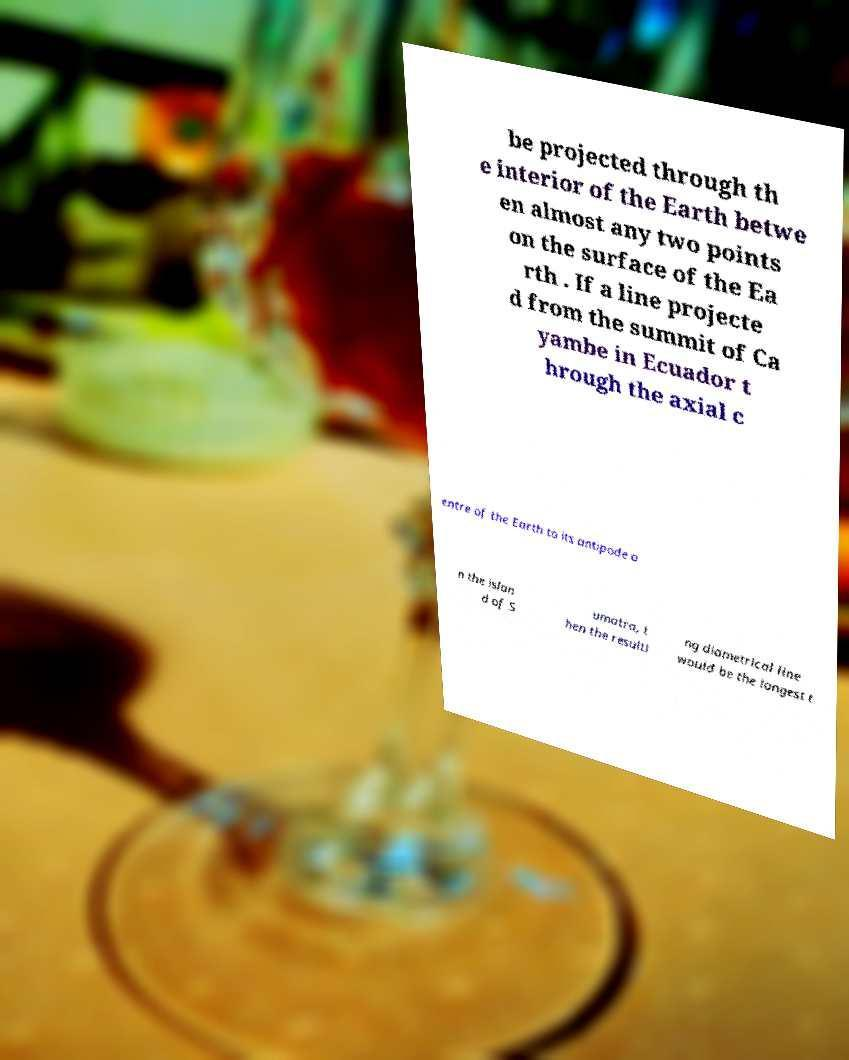What messages or text are displayed in this image? I need them in a readable, typed format. be projected through th e interior of the Earth betwe en almost any two points on the surface of the Ea rth . If a line projecte d from the summit of Ca yambe in Ecuador t hrough the axial c entre of the Earth to its antipode o n the islan d of S umatra, t hen the resulti ng diametrical line would be the longest t 